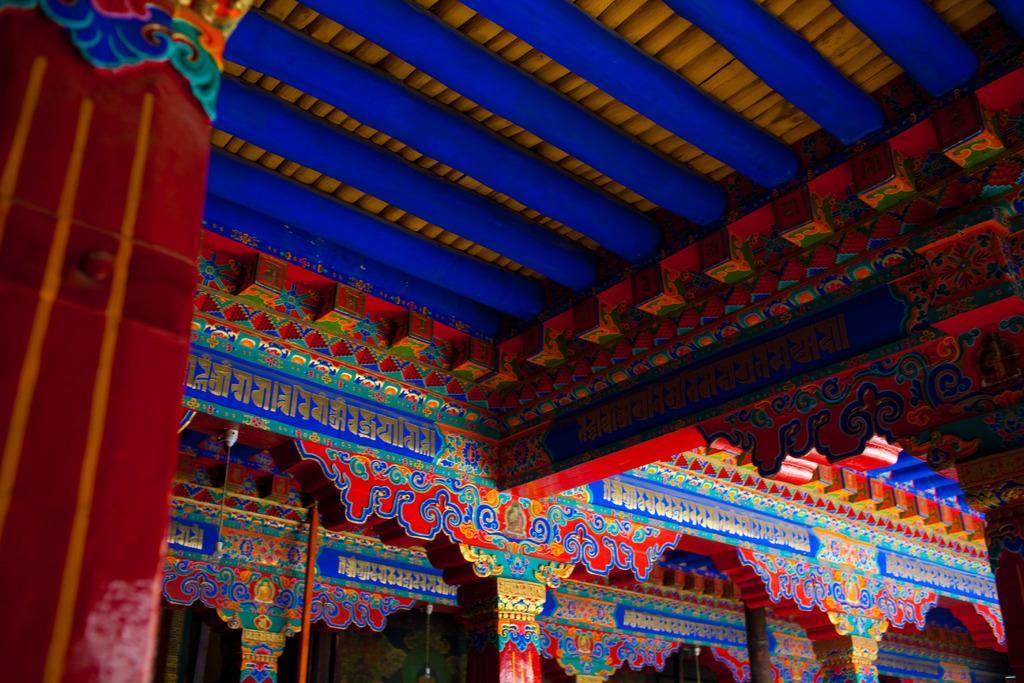In one or two sentences, can you explain what this image depicts? In this picture I can see there is a ceiling and it has some colorful designs and the pillars are in red in color. 